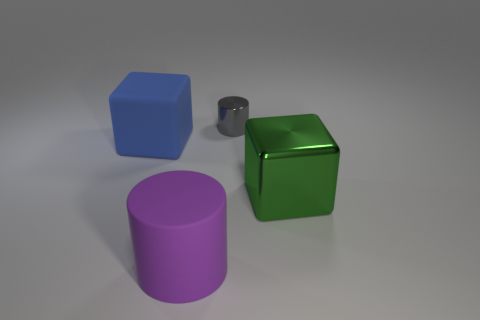Add 1 tiny rubber things. How many objects exist? 5 Subtract 1 cubes. How many cubes are left? 1 Add 2 big blocks. How many big blocks exist? 4 Subtract 1 green blocks. How many objects are left? 3 Subtract all red cylinders. Subtract all yellow balls. How many cylinders are left? 2 Subtract all large green things. Subtract all gray things. How many objects are left? 2 Add 1 large purple objects. How many large purple objects are left? 2 